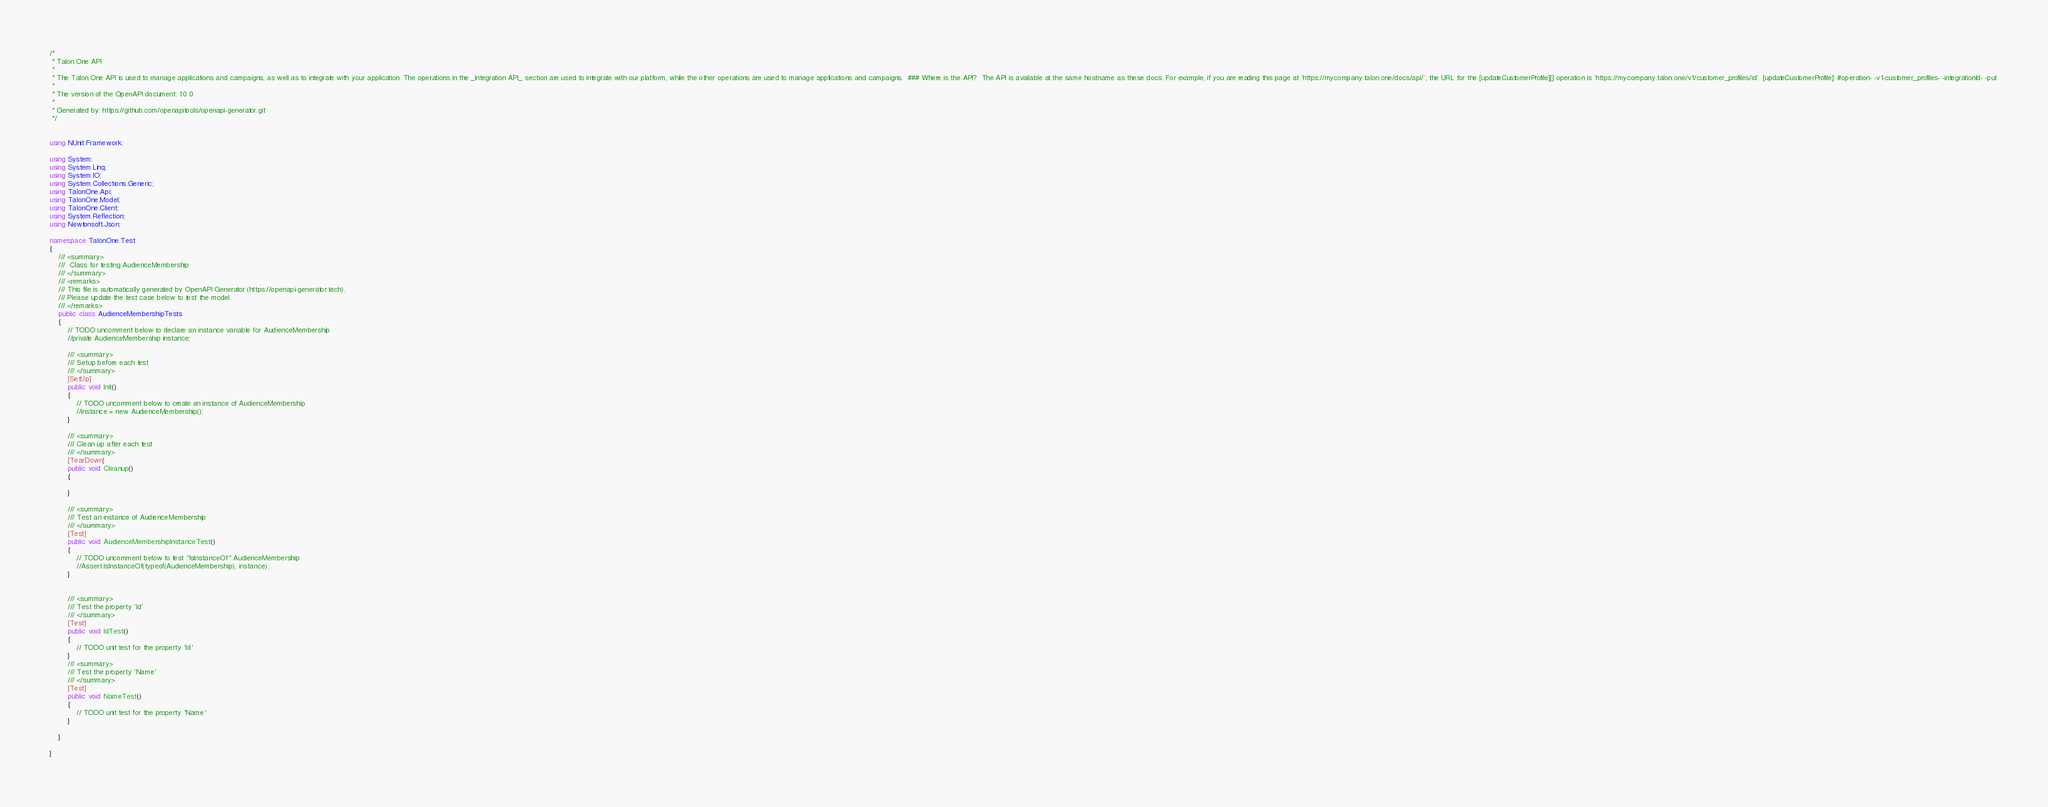<code> <loc_0><loc_0><loc_500><loc_500><_C#_>/* 
 * Talon.One API
 *
 * The Talon.One API is used to manage applications and campaigns, as well as to integrate with your application. The operations in the _Integration API_ section are used to integrate with our platform, while the other operations are used to manage applications and campaigns.  ### Where is the API?  The API is available at the same hostname as these docs. For example, if you are reading this page at `https://mycompany.talon.one/docs/api/`, the URL for the [updateCustomerProfile][] operation is `https://mycompany.talon.one/v1/customer_profiles/id`  [updateCustomerProfile]: #operation- -v1-customer_profiles- -integrationId- -put 
 *
 * The version of the OpenAPI document: 1.0.0
 * 
 * Generated by: https://github.com/openapitools/openapi-generator.git
 */


using NUnit.Framework;

using System;
using System.Linq;
using System.IO;
using System.Collections.Generic;
using TalonOne.Api;
using TalonOne.Model;
using TalonOne.Client;
using System.Reflection;
using Newtonsoft.Json;

namespace TalonOne.Test
{
    /// <summary>
    ///  Class for testing AudienceMembership
    /// </summary>
    /// <remarks>
    /// This file is automatically generated by OpenAPI Generator (https://openapi-generator.tech).
    /// Please update the test case below to test the model.
    /// </remarks>
    public class AudienceMembershipTests
    {
        // TODO uncomment below to declare an instance variable for AudienceMembership
        //private AudienceMembership instance;

        /// <summary>
        /// Setup before each test
        /// </summary>
        [SetUp]
        public void Init()
        {
            // TODO uncomment below to create an instance of AudienceMembership
            //instance = new AudienceMembership();
        }

        /// <summary>
        /// Clean up after each test
        /// </summary>
        [TearDown]
        public void Cleanup()
        {

        }

        /// <summary>
        /// Test an instance of AudienceMembership
        /// </summary>
        [Test]
        public void AudienceMembershipInstanceTest()
        {
            // TODO uncomment below to test "IsInstanceOf" AudienceMembership
            //Assert.IsInstanceOf(typeof(AudienceMembership), instance);
        }


        /// <summary>
        /// Test the property 'Id'
        /// </summary>
        [Test]
        public void IdTest()
        {
            // TODO unit test for the property 'Id'
        }
        /// <summary>
        /// Test the property 'Name'
        /// </summary>
        [Test]
        public void NameTest()
        {
            // TODO unit test for the property 'Name'
        }

    }

}
</code> 